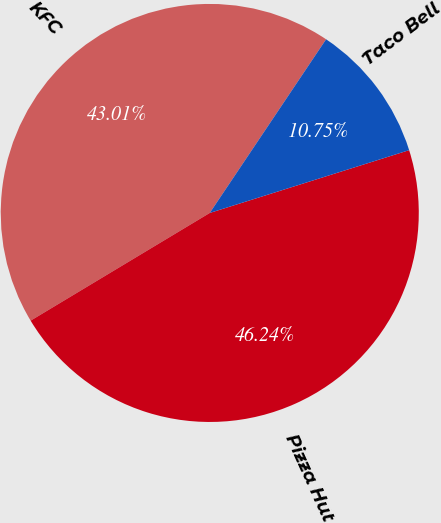Convert chart to OTSL. <chart><loc_0><loc_0><loc_500><loc_500><pie_chart><fcel>KFC<fcel>Pizza Hut<fcel>Taco Bell<nl><fcel>43.01%<fcel>46.24%<fcel>10.75%<nl></chart> 